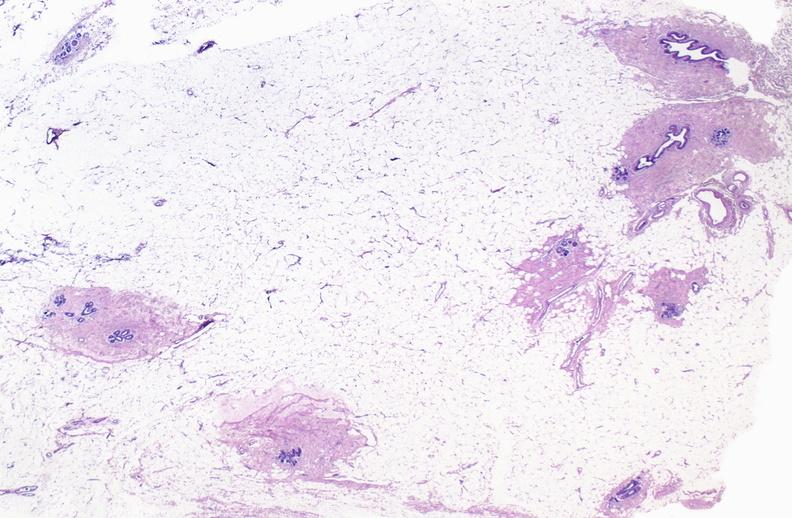what does this image show?
Answer the question using a single word or phrase. Normal breast 